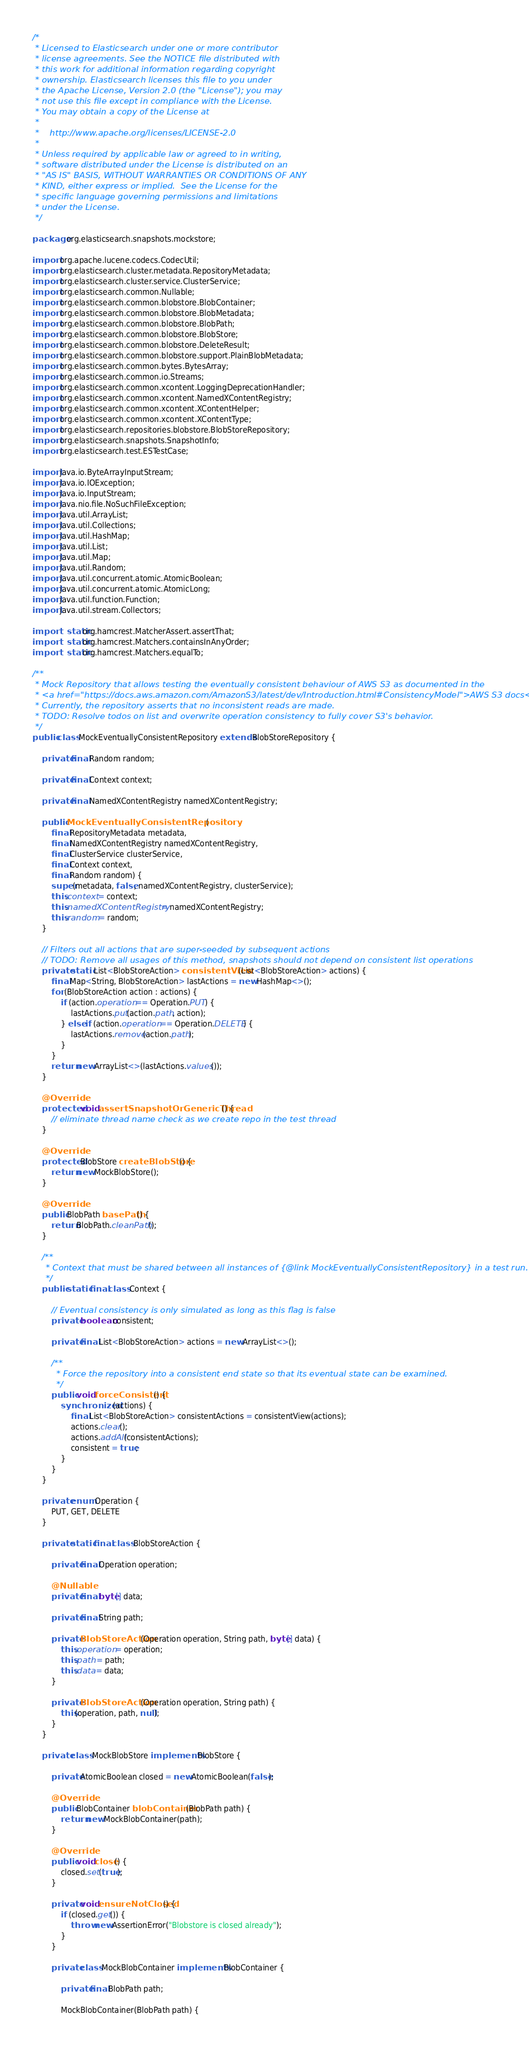<code> <loc_0><loc_0><loc_500><loc_500><_Java_>/*
 * Licensed to Elasticsearch under one or more contributor
 * license agreements. See the NOTICE file distributed with
 * this work for additional information regarding copyright
 * ownership. Elasticsearch licenses this file to you under
 * the Apache License, Version 2.0 (the "License"); you may
 * not use this file except in compliance with the License.
 * You may obtain a copy of the License at
 *
 *    http://www.apache.org/licenses/LICENSE-2.0
 *
 * Unless required by applicable law or agreed to in writing,
 * software distributed under the License is distributed on an
 * "AS IS" BASIS, WITHOUT WARRANTIES OR CONDITIONS OF ANY
 * KIND, either express or implied.  See the License for the
 * specific language governing permissions and limitations
 * under the License.
 */

package org.elasticsearch.snapshots.mockstore;

import org.apache.lucene.codecs.CodecUtil;
import org.elasticsearch.cluster.metadata.RepositoryMetadata;
import org.elasticsearch.cluster.service.ClusterService;
import org.elasticsearch.common.Nullable;
import org.elasticsearch.common.blobstore.BlobContainer;
import org.elasticsearch.common.blobstore.BlobMetadata;
import org.elasticsearch.common.blobstore.BlobPath;
import org.elasticsearch.common.blobstore.BlobStore;
import org.elasticsearch.common.blobstore.DeleteResult;
import org.elasticsearch.common.blobstore.support.PlainBlobMetadata;
import org.elasticsearch.common.bytes.BytesArray;
import org.elasticsearch.common.io.Streams;
import org.elasticsearch.common.xcontent.LoggingDeprecationHandler;
import org.elasticsearch.common.xcontent.NamedXContentRegistry;
import org.elasticsearch.common.xcontent.XContentHelper;
import org.elasticsearch.common.xcontent.XContentType;
import org.elasticsearch.repositories.blobstore.BlobStoreRepository;
import org.elasticsearch.snapshots.SnapshotInfo;
import org.elasticsearch.test.ESTestCase;

import java.io.ByteArrayInputStream;
import java.io.IOException;
import java.io.InputStream;
import java.nio.file.NoSuchFileException;
import java.util.ArrayList;
import java.util.Collections;
import java.util.HashMap;
import java.util.List;
import java.util.Map;
import java.util.Random;
import java.util.concurrent.atomic.AtomicBoolean;
import java.util.concurrent.atomic.AtomicLong;
import java.util.function.Function;
import java.util.stream.Collectors;

import static org.hamcrest.MatcherAssert.assertThat;
import static org.hamcrest.Matchers.containsInAnyOrder;
import static org.hamcrest.Matchers.equalTo;

/**
 * Mock Repository that allows testing the eventually consistent behaviour of AWS S3 as documented in the
 * <a href="https://docs.aws.amazon.com/AmazonS3/latest/dev/Introduction.html#ConsistencyModel">AWS S3 docs</a>.
 * Currently, the repository asserts that no inconsistent reads are made.
 * TODO: Resolve todos on list and overwrite operation consistency to fully cover S3's behavior.
 */
public class MockEventuallyConsistentRepository extends BlobStoreRepository {

    private final Random random;

    private final Context context;

    private final NamedXContentRegistry namedXContentRegistry;

    public MockEventuallyConsistentRepository(
        final RepositoryMetadata metadata,
        final NamedXContentRegistry namedXContentRegistry,
        final ClusterService clusterService,
        final Context context,
        final Random random) {
        super(metadata, false, namedXContentRegistry, clusterService);
        this.context = context;
        this.namedXContentRegistry = namedXContentRegistry;
        this.random = random;
    }

    // Filters out all actions that are super-seeded by subsequent actions
    // TODO: Remove all usages of this method, snapshots should not depend on consistent list operations
    private static List<BlobStoreAction> consistentView(List<BlobStoreAction> actions) {
        final Map<String, BlobStoreAction> lastActions = new HashMap<>();
        for (BlobStoreAction action : actions) {
            if (action.operation == Operation.PUT) {
                lastActions.put(action.path, action);
            } else if (action.operation == Operation.DELETE) {
                lastActions.remove(action.path);
            }
        }
        return new ArrayList<>(lastActions.values());
    }

    @Override
    protected void assertSnapshotOrGenericThread() {
        // eliminate thread name check as we create repo in the test thread
    }

    @Override
    protected BlobStore createBlobStore() {
        return new MockBlobStore();
    }

    @Override
    public BlobPath basePath() {
        return BlobPath.cleanPath();
    }

    /**
     * Context that must be shared between all instances of {@link MockEventuallyConsistentRepository} in a test run.
     */
    public static final class Context {

        // Eventual consistency is only simulated as long as this flag is false
        private boolean consistent;

        private final List<BlobStoreAction> actions = new ArrayList<>();

        /**
         * Force the repository into a consistent end state so that its eventual state can be examined.
         */
        public void forceConsistent() {
            synchronized (actions) {
                final List<BlobStoreAction> consistentActions = consistentView(actions);
                actions.clear();
                actions.addAll(consistentActions);
                consistent = true;
            }
        }
    }

    private enum Operation {
        PUT, GET, DELETE
    }

    private static final class BlobStoreAction {

        private final Operation operation;

        @Nullable
        private final byte[] data;

        private final String path;

        private BlobStoreAction(Operation operation, String path, byte[] data) {
            this.operation = operation;
            this.path = path;
            this.data = data;
        }

        private BlobStoreAction(Operation operation, String path) {
            this(operation, path, null);
        }
    }

    private class MockBlobStore implements BlobStore {

        private AtomicBoolean closed = new AtomicBoolean(false);

        @Override
        public BlobContainer blobContainer(BlobPath path) {
            return new MockBlobContainer(path);
        }

        @Override
        public void close() {
            closed.set(true);
        }

        private void ensureNotClosed() {
            if (closed.get()) {
                throw new AssertionError("Blobstore is closed already");
            }
        }

        private class MockBlobContainer implements BlobContainer {

            private final BlobPath path;

            MockBlobContainer(BlobPath path) {</code> 